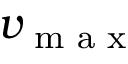<formula> <loc_0><loc_0><loc_500><loc_500>v _ { \max }</formula> 